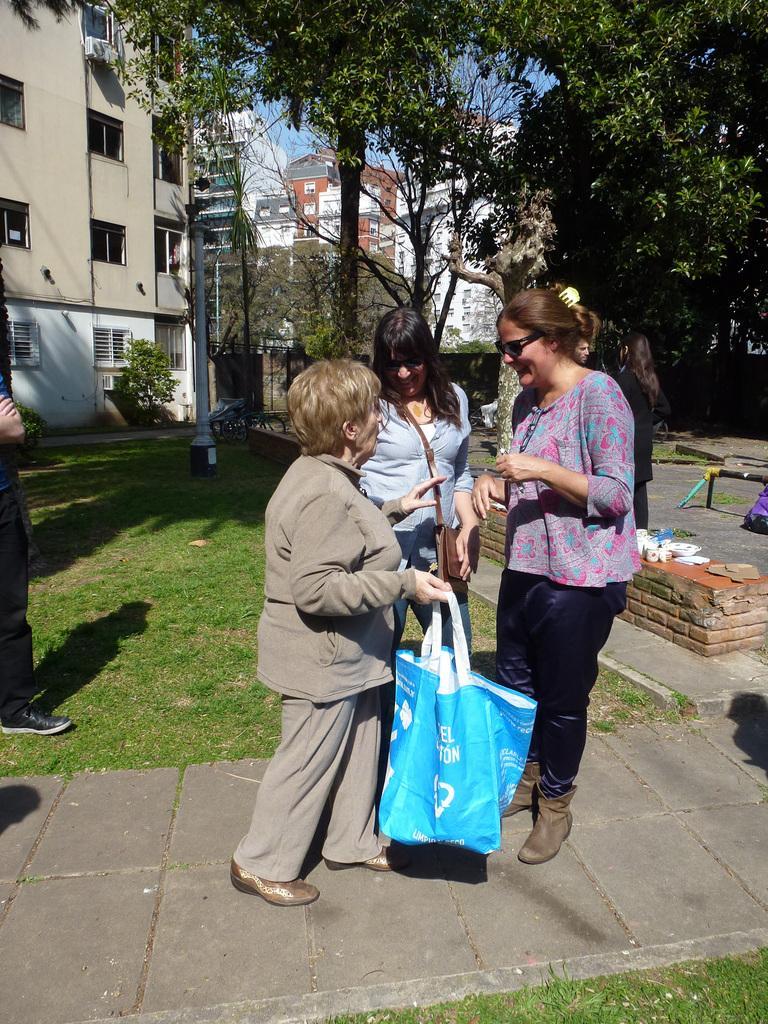Describe this image in one or two sentences. Here we can see three women standing on the ground and among them a woman is holding bag in her hand and another woman is carrying bag on her shoulder. In the background there are few persons,trees,buildings,windows,plants,some objects on a platform,a bag on the floor. On the left we can see a person is standing on the ground. 